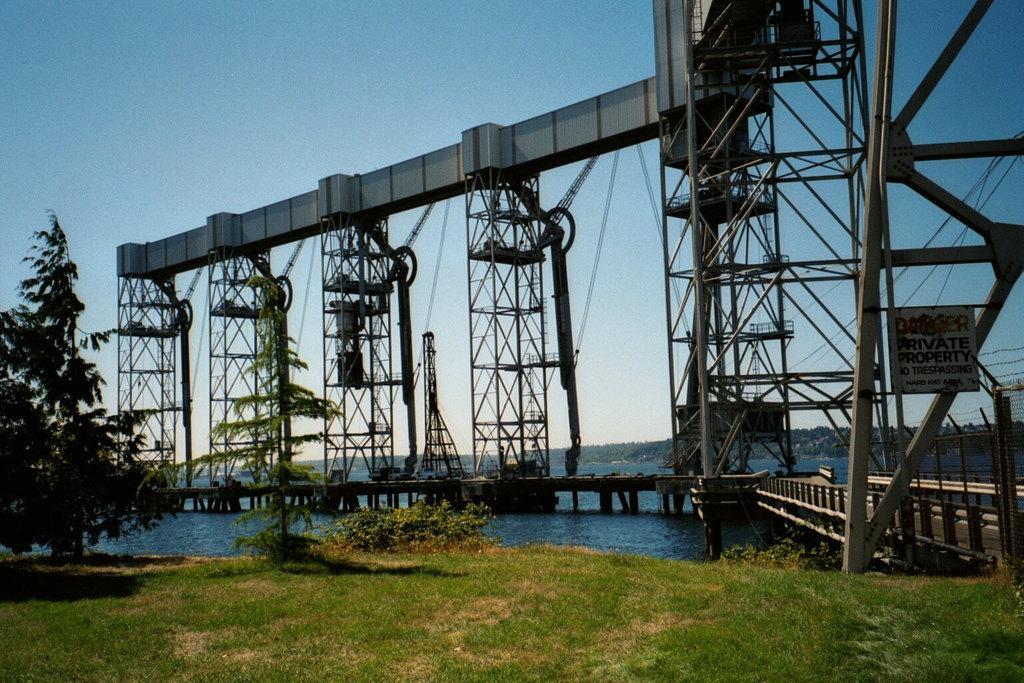Describe this image in one or two sentences. In the center of the image we can see a bridge. In the background of the image we can see the trees, water, wires. On the right side of the image we can see a board. On the board we can see the text. At the bottom of the image we can see the ground. At the top of the image we can see the sky. 